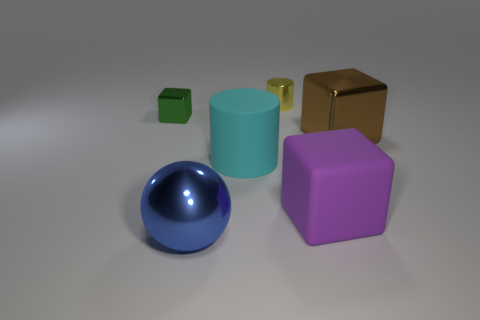The tiny yellow shiny thing that is behind the brown metal object has what shape?
Ensure brevity in your answer.  Cylinder. How many things are large yellow matte cubes or metallic blocks?
Make the answer very short. 2. Do the cyan cylinder and the metallic thing that is on the right side of the large purple block have the same size?
Your response must be concise. Yes. What number of other things are there of the same material as the tiny yellow thing
Ensure brevity in your answer.  3. How many objects are either big metallic things that are to the left of the brown metal object or objects right of the large blue shiny sphere?
Your answer should be compact. 5. There is a big brown object that is the same shape as the green thing; what is its material?
Your response must be concise. Metal. Are any small gray matte objects visible?
Keep it short and to the point. No. How big is the thing that is behind the big brown metallic object and on the left side of the small yellow metallic cylinder?
Offer a very short reply. Small. The small green object is what shape?
Ensure brevity in your answer.  Cube. Is there a blue ball in front of the tiny object that is right of the tiny green shiny block?
Make the answer very short. Yes. 